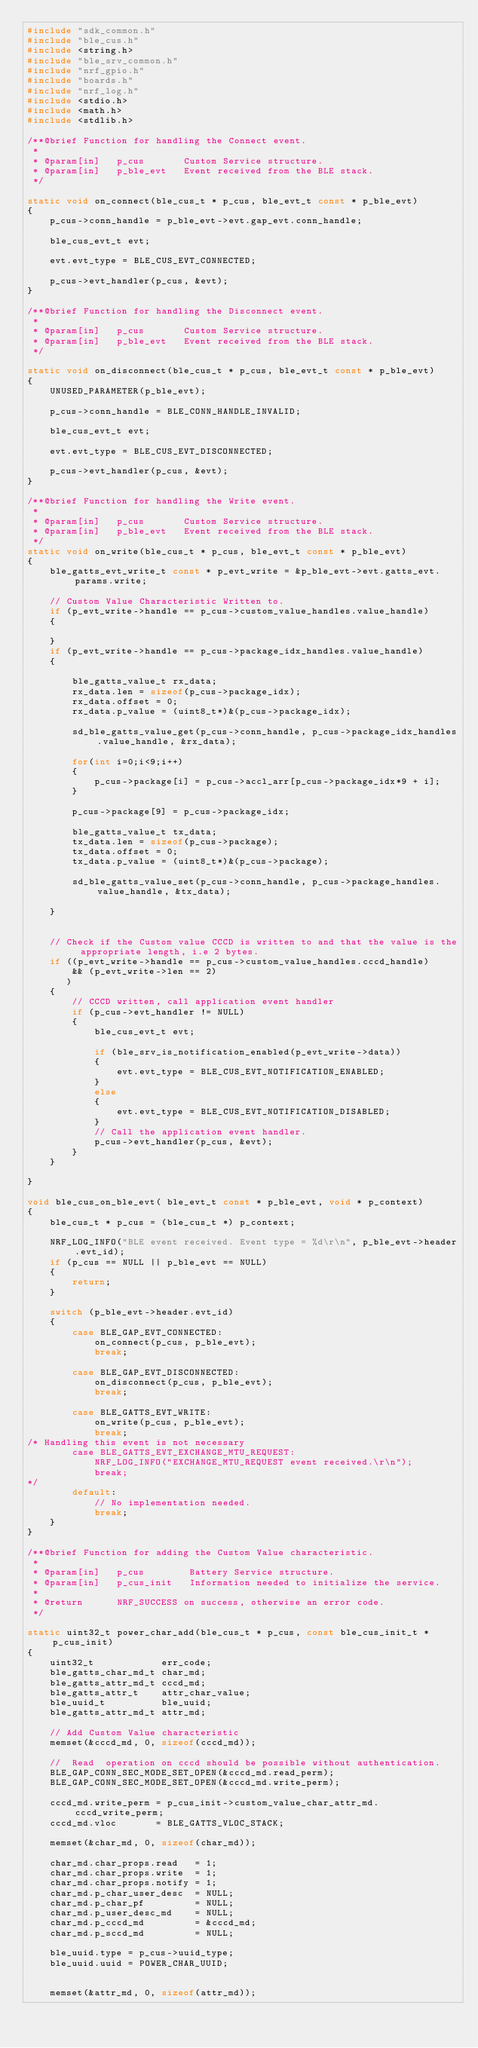<code> <loc_0><loc_0><loc_500><loc_500><_C_>#include "sdk_common.h"
#include "ble_cus.h"
#include <string.h>
#include "ble_srv_common.h"
#include "nrf_gpio.h"
#include "boards.h"
#include "nrf_log.h"
#include <stdio.h>
#include <math.h>
#include <stdlib.h>

/**@brief Function for handling the Connect event.
 *
 * @param[in]   p_cus       Custom Service structure.
 * @param[in]   p_ble_evt   Event received from the BLE stack.
 */

static void on_connect(ble_cus_t * p_cus, ble_evt_t const * p_ble_evt)
{
    p_cus->conn_handle = p_ble_evt->evt.gap_evt.conn_handle;

    ble_cus_evt_t evt;

    evt.evt_type = BLE_CUS_EVT_CONNECTED;

    p_cus->evt_handler(p_cus, &evt);
}

/**@brief Function for handling the Disconnect event.
 *
 * @param[in]   p_cus       Custom Service structure.
 * @param[in]   p_ble_evt   Event received from the BLE stack.
 */

static void on_disconnect(ble_cus_t * p_cus, ble_evt_t const * p_ble_evt)
{
    UNUSED_PARAMETER(p_ble_evt);

    p_cus->conn_handle = BLE_CONN_HANDLE_INVALID;
    
    ble_cus_evt_t evt;

    evt.evt_type = BLE_CUS_EVT_DISCONNECTED;

    p_cus->evt_handler(p_cus, &evt);
}

/**@brief Function for handling the Write event.
 *
 * @param[in]   p_cus       Custom Service structure.
 * @param[in]   p_ble_evt   Event received from the BLE stack.
 */
static void on_write(ble_cus_t * p_cus, ble_evt_t const * p_ble_evt)
{
    ble_gatts_evt_write_t const * p_evt_write = &p_ble_evt->evt.gatts_evt.params.write;
    
    // Custom Value Characteristic Written to.
    if (p_evt_write->handle == p_cus->custom_value_handles.value_handle)
    {
 
    }
    if (p_evt_write->handle == p_cus->package_idx_handles.value_handle)
    {
        
        ble_gatts_value_t rx_data;
        rx_data.len = sizeof(p_cus->package_idx);
        rx_data.offset = 0;
        rx_data.p_value = (uint8_t*)&(p_cus->package_idx);

        sd_ble_gatts_value_get(p_cus->conn_handle, p_cus->package_idx_handles.value_handle, &rx_data);
        
        for(int i=0;i<9;i++)
        {
            p_cus->package[i] = p_cus->accl_arr[p_cus->package_idx*9 + i];
        }
        
        p_cus->package[9] = p_cus->package_idx;

        ble_gatts_value_t tx_data;
        tx_data.len = sizeof(p_cus->package);
        tx_data.offset = 0;
        tx_data.p_value = (uint8_t*)&(p_cus->package);

        sd_ble_gatts_value_set(p_cus->conn_handle, p_cus->package_handles.value_handle, &tx_data); 
        
    }


    // Check if the Custom value CCCD is written to and that the value is the appropriate length, i.e 2 bytes.
    if ((p_evt_write->handle == p_cus->custom_value_handles.cccd_handle)
        && (p_evt_write->len == 2)
       )
    {
        // CCCD written, call application event handler
        if (p_cus->evt_handler != NULL)
        {
            ble_cus_evt_t evt;

            if (ble_srv_is_notification_enabled(p_evt_write->data))
            {
                evt.evt_type = BLE_CUS_EVT_NOTIFICATION_ENABLED;
            }
            else
            {
                evt.evt_type = BLE_CUS_EVT_NOTIFICATION_DISABLED;
            }
            // Call the application event handler.
            p_cus->evt_handler(p_cus, &evt);
        }
    }

}

void ble_cus_on_ble_evt( ble_evt_t const * p_ble_evt, void * p_context)
{
    ble_cus_t * p_cus = (ble_cus_t *) p_context;
    
    NRF_LOG_INFO("BLE event received. Event type = %d\r\n", p_ble_evt->header.evt_id); 
    if (p_cus == NULL || p_ble_evt == NULL)
    {
        return;
    }
    
    switch (p_ble_evt->header.evt_id)
    {
        case BLE_GAP_EVT_CONNECTED:
            on_connect(p_cus, p_ble_evt);
            break;

        case BLE_GAP_EVT_DISCONNECTED:
            on_disconnect(p_cus, p_ble_evt);
            break;

        case BLE_GATTS_EVT_WRITE:
            on_write(p_cus, p_ble_evt);
            break;
/* Handling this event is not necessary
        case BLE_GATTS_EVT_EXCHANGE_MTU_REQUEST:
            NRF_LOG_INFO("EXCHANGE_MTU_REQUEST event received.\r\n");
            break;
*/
        default:
            // No implementation needed.
            break;
    }
}

/**@brief Function for adding the Custom Value characteristic.
 *
 * @param[in]   p_cus        Battery Service structure.
 * @param[in]   p_cus_init   Information needed to initialize the service.
 *
 * @return      NRF_SUCCESS on success, otherwise an error code.
 */

static uint32_t power_char_add(ble_cus_t * p_cus, const ble_cus_init_t * p_cus_init)
{
    uint32_t            err_code;
    ble_gatts_char_md_t char_md;
    ble_gatts_attr_md_t cccd_md;
    ble_gatts_attr_t    attr_char_value;
    ble_uuid_t          ble_uuid;
    ble_gatts_attr_md_t attr_md;

    // Add Custom Value characteristic
    memset(&cccd_md, 0, sizeof(cccd_md));

    //  Read  operation on cccd should be possible without authentication.
    BLE_GAP_CONN_SEC_MODE_SET_OPEN(&cccd_md.read_perm);
    BLE_GAP_CONN_SEC_MODE_SET_OPEN(&cccd_md.write_perm);
    
    cccd_md.write_perm = p_cus_init->custom_value_char_attr_md.cccd_write_perm;
    cccd_md.vloc       = BLE_GATTS_VLOC_STACK;

    memset(&char_md, 0, sizeof(char_md));

    char_md.char_props.read   = 1;
    char_md.char_props.write  = 1;
    char_md.char_props.notify = 1; 
    char_md.p_char_user_desc  = NULL;
    char_md.p_char_pf         = NULL;
    char_md.p_user_desc_md    = NULL;
    char_md.p_cccd_md         = &cccd_md; 
    char_md.p_sccd_md         = NULL;
		
    ble_uuid.type = p_cus->uuid_type;
    ble_uuid.uuid = POWER_CHAR_UUID;
    

    memset(&attr_md, 0, sizeof(attr_md));
</code> 